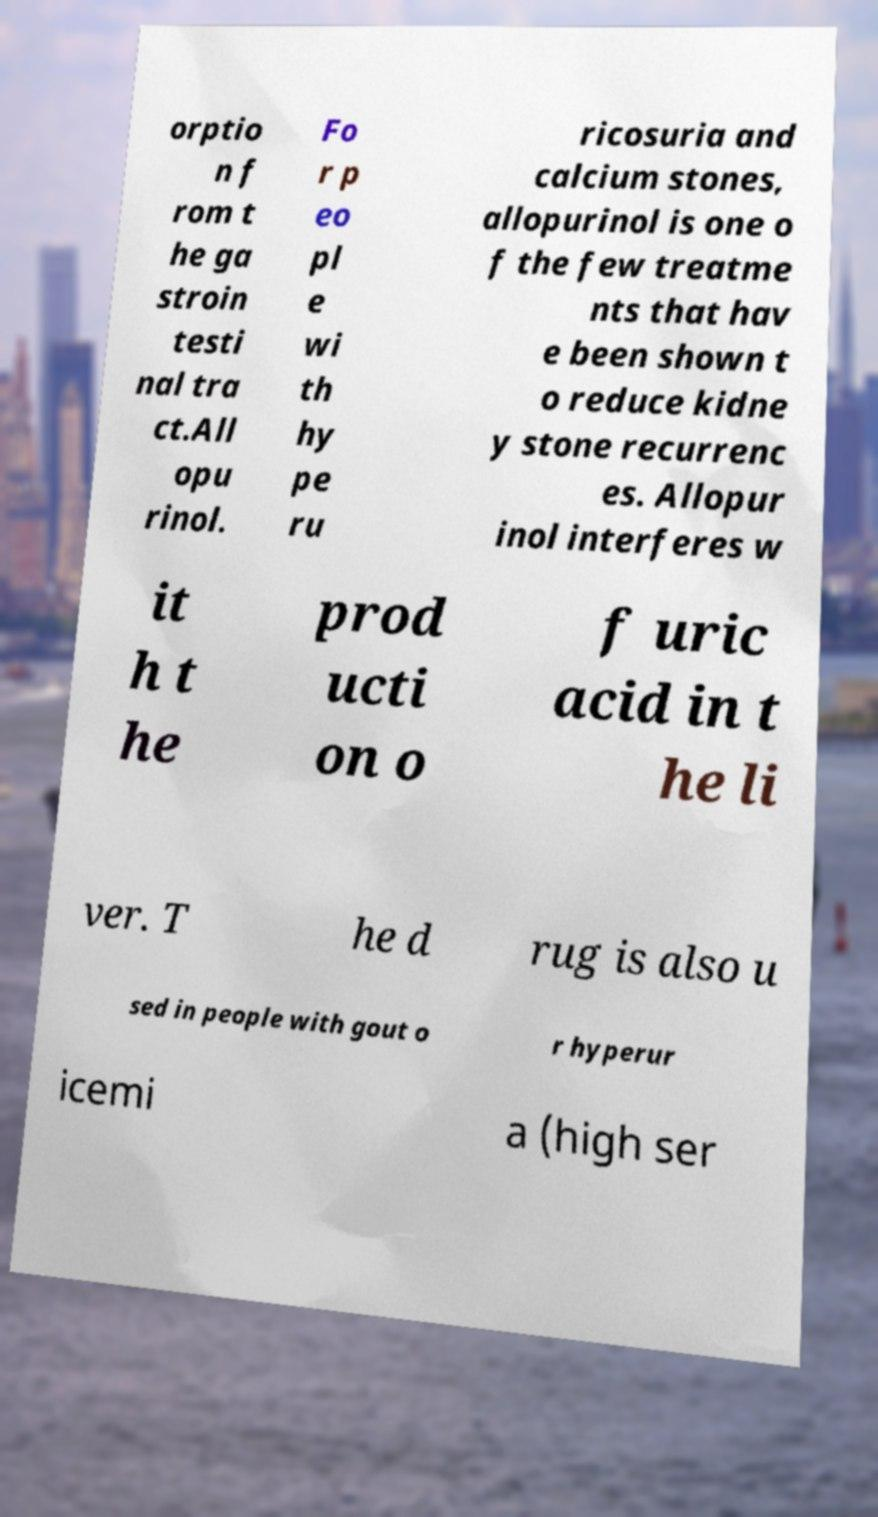For documentation purposes, I need the text within this image transcribed. Could you provide that? orptio n f rom t he ga stroin testi nal tra ct.All opu rinol. Fo r p eo pl e wi th hy pe ru ricosuria and calcium stones, allopurinol is one o f the few treatme nts that hav e been shown t o reduce kidne y stone recurrenc es. Allopur inol interferes w it h t he prod ucti on o f uric acid in t he li ver. T he d rug is also u sed in people with gout o r hyperur icemi a (high ser 